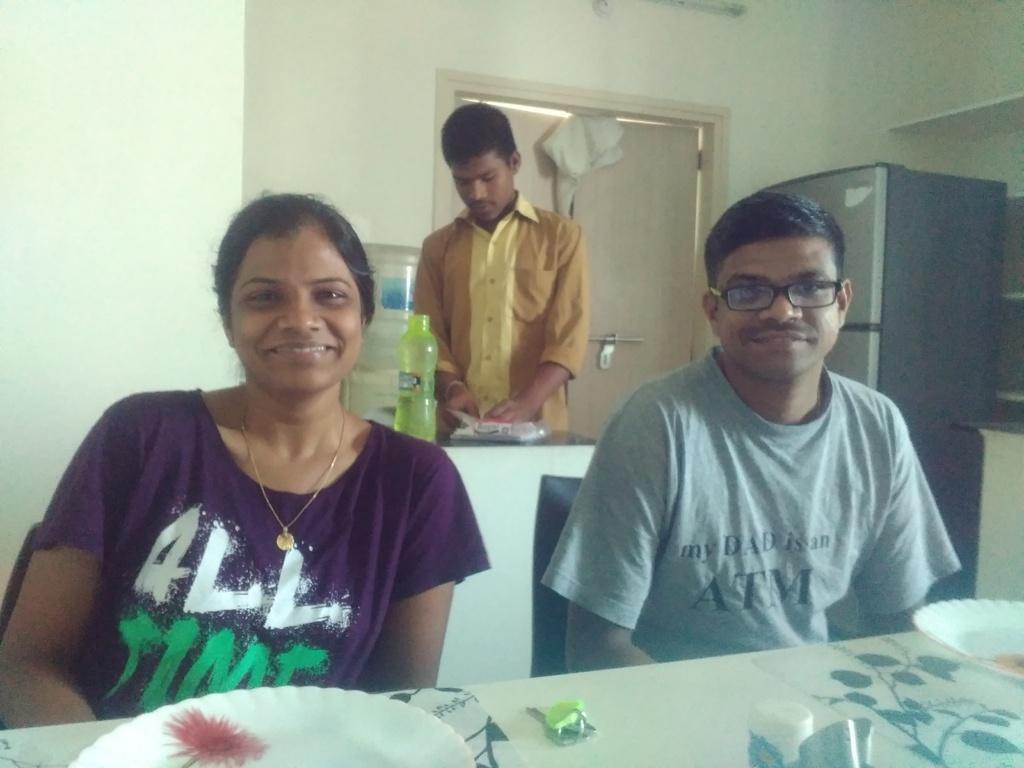Please provide a concise description of this image. This picture is clicked inside the room. Here, we see the woman in purple T-shirt and the man in grey T-shirt are sitting on the chairs. In front of them, we see a table on which plates are placed. Behind them, we see a counter top on which water bottle is placed. Behind him, we see a white wall, door and the refrigerator. 